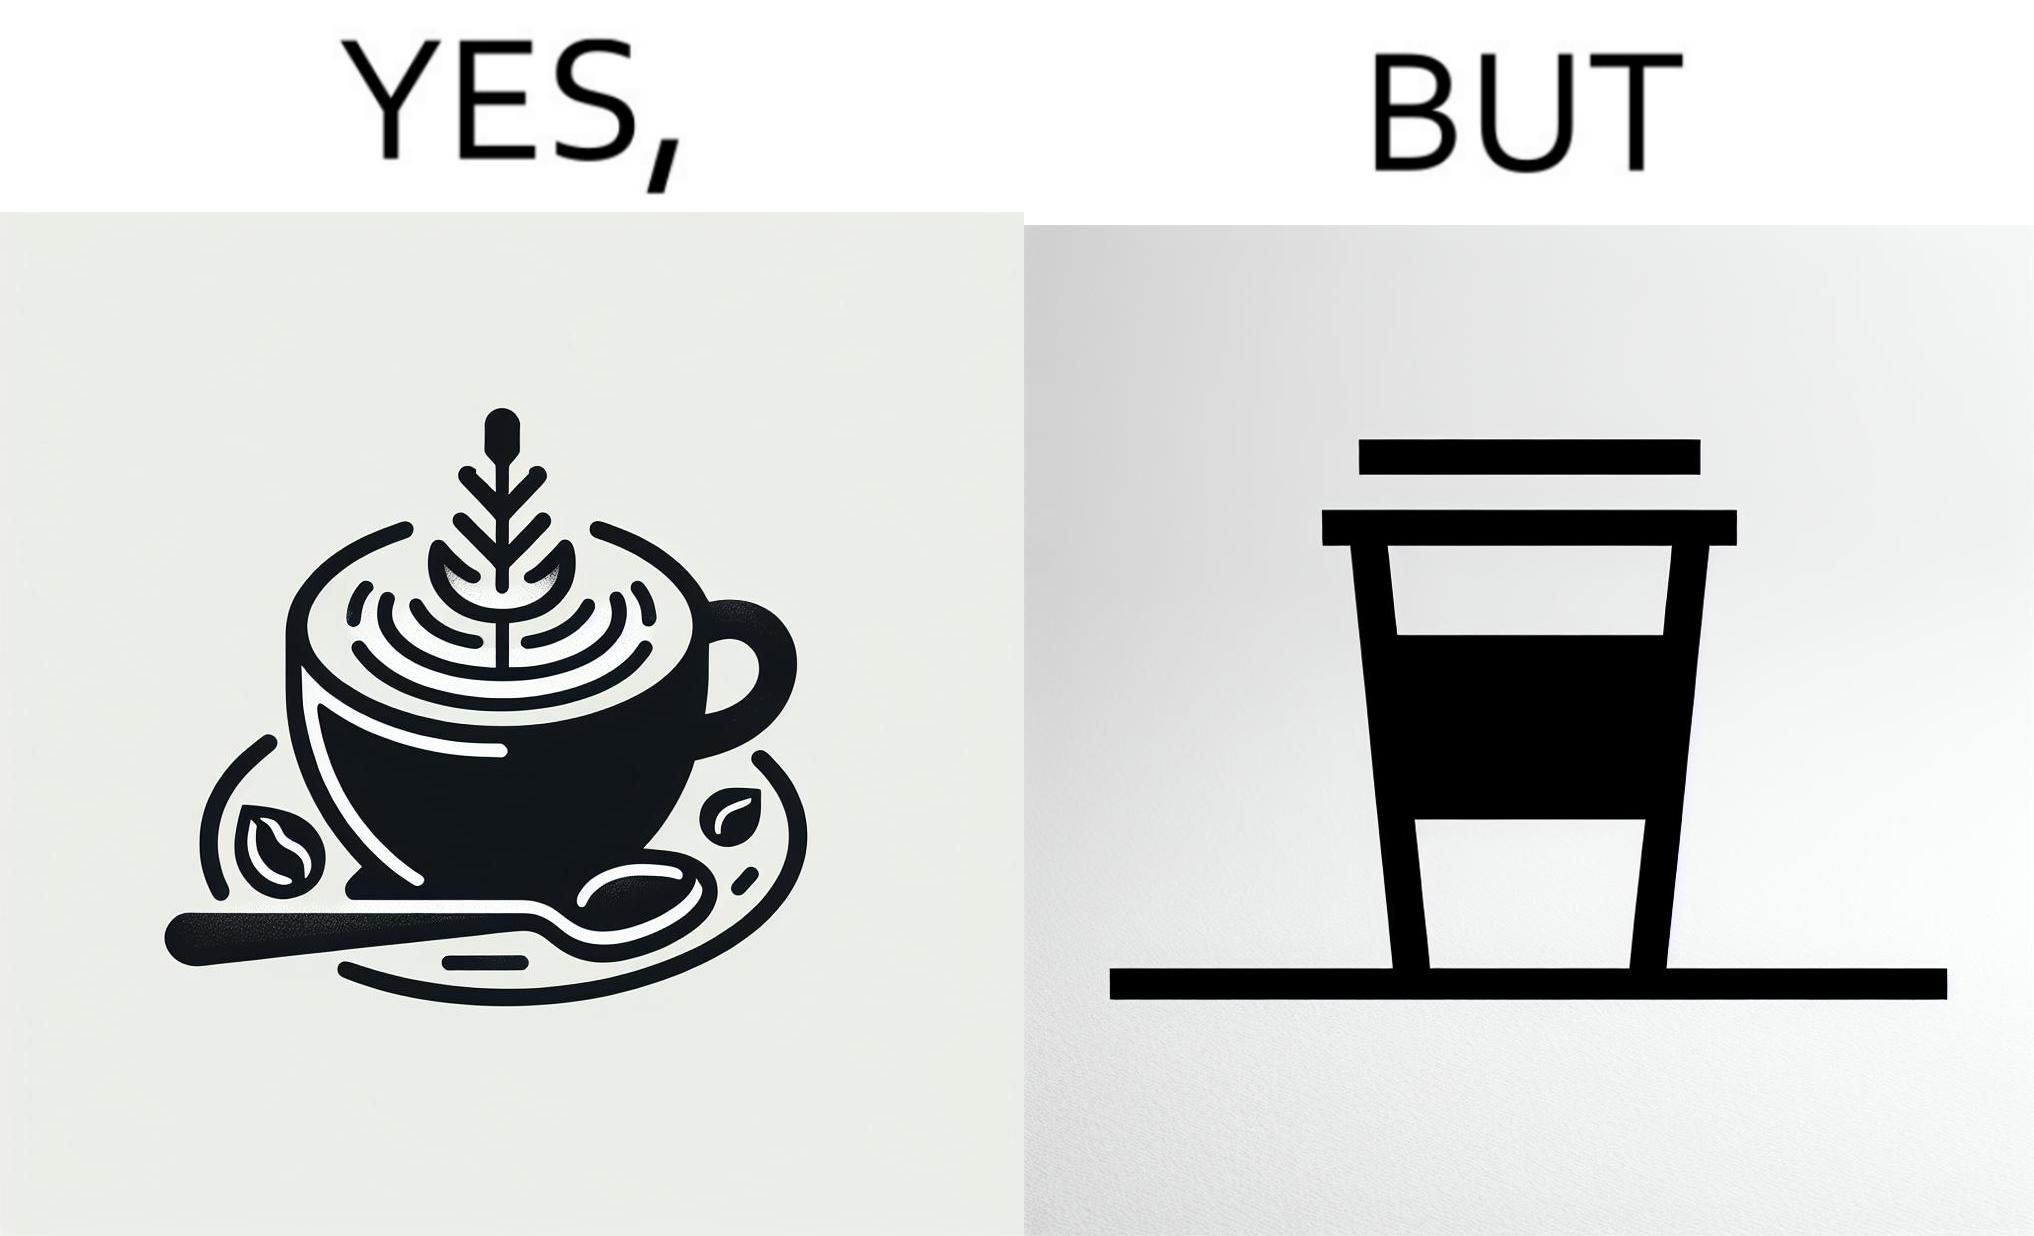Describe the satirical element in this image. The images are funny since it shows how someone has put effort into a cup of coffee to do latte art on it only for it to be invisible after a lid is put on the coffee cup before serving to a customer 